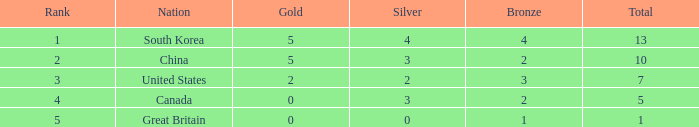What is Nation, when Rank is greater than 2, when Total is greater than 1, and when Bronze is less than 3? Canada. 